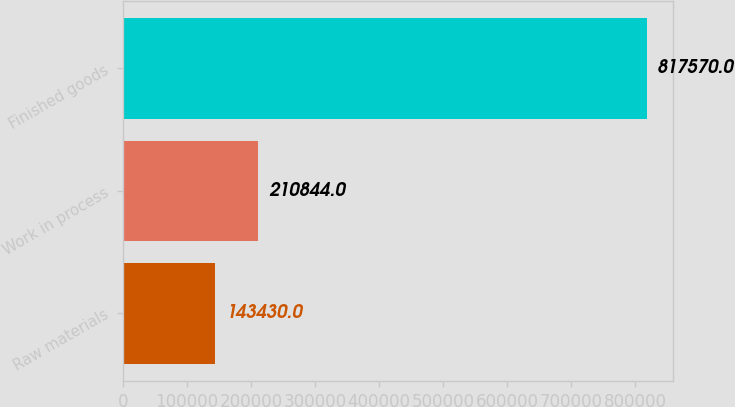Convert chart to OTSL. <chart><loc_0><loc_0><loc_500><loc_500><bar_chart><fcel>Raw materials<fcel>Work in process<fcel>Finished goods<nl><fcel>143430<fcel>210844<fcel>817570<nl></chart> 